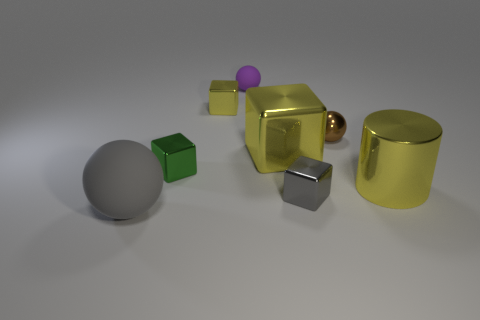What size is the cylinder that is the same color as the big block?
Provide a short and direct response. Large. Is the shape of the matte object behind the gray rubber thing the same as  the big gray thing?
Your answer should be very brief. Yes. Are there fewer gray rubber balls than gray objects?
Offer a terse response. Yes. Are there any other things that have the same color as the metallic sphere?
Provide a short and direct response. No. There is a object that is behind the tiny yellow object; what is its shape?
Your answer should be very brief. Sphere. Is the color of the big rubber thing the same as the tiny cube to the right of the small yellow object?
Provide a short and direct response. Yes. Are there an equal number of large yellow cylinders that are on the left side of the cylinder and blocks that are on the right side of the green thing?
Your answer should be compact. No. How many other objects are there of the same size as the purple object?
Ensure brevity in your answer.  4. How big is the green thing?
Your answer should be very brief. Small. Are the purple sphere and the sphere in front of the tiny brown thing made of the same material?
Offer a very short reply. Yes. 